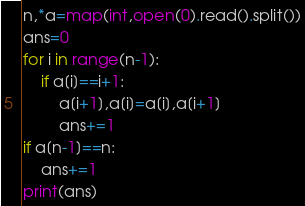Convert code to text. <code><loc_0><loc_0><loc_500><loc_500><_Python_>n,*a=map(int,open(0).read().split())
ans=0
for i in range(n-1):
    if a[i]==i+1:
        a[i+1],a[i]=a[i],a[i+1]
        ans+=1
if a[n-1]==n:
    ans+=1
print(ans)
</code> 